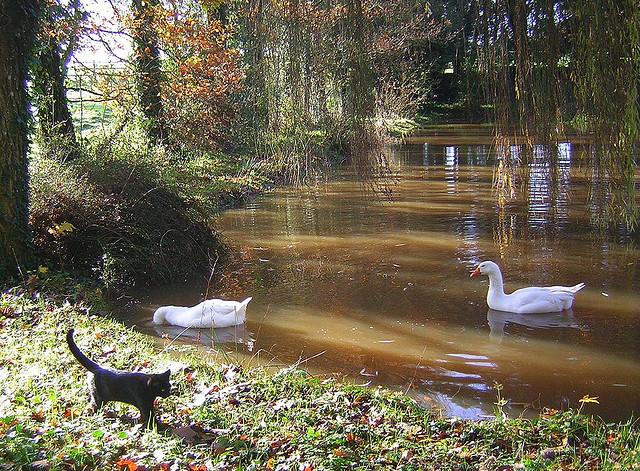Is the cat young?
Give a very brief answer. Yes. What color is the water?
Give a very brief answer. Brown. How many reflections in the water are there?
Answer briefly. 2. 